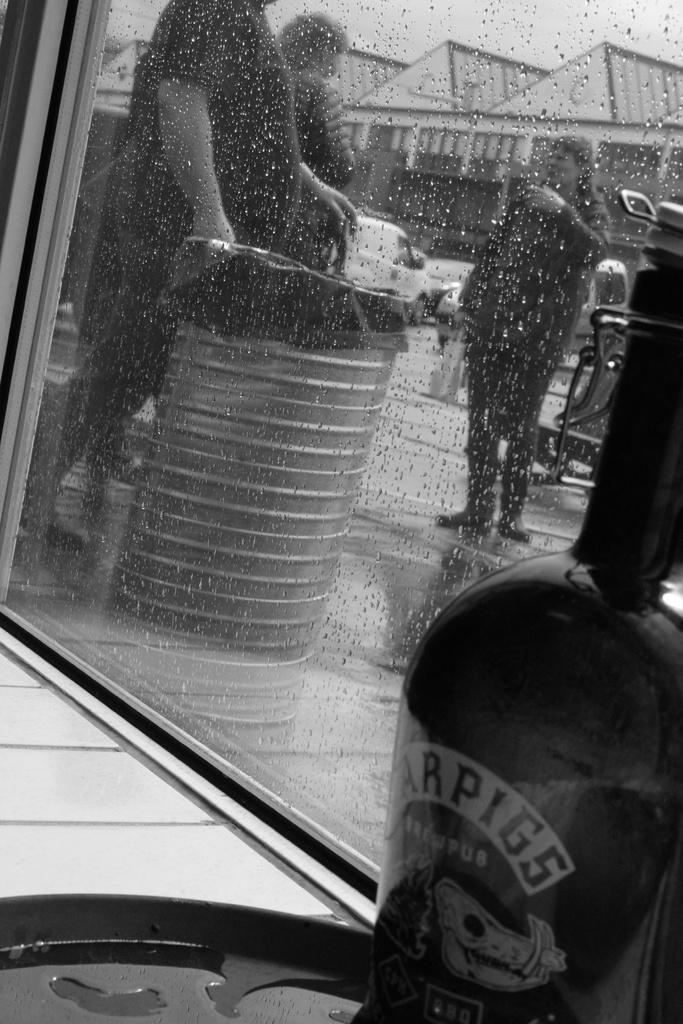Describe this image in one or two sentences. There is a bottle on the right side of the image on a table and there is a glass window in the center of the image, there are people, vehicles, houses, and a barrel outside the window. 